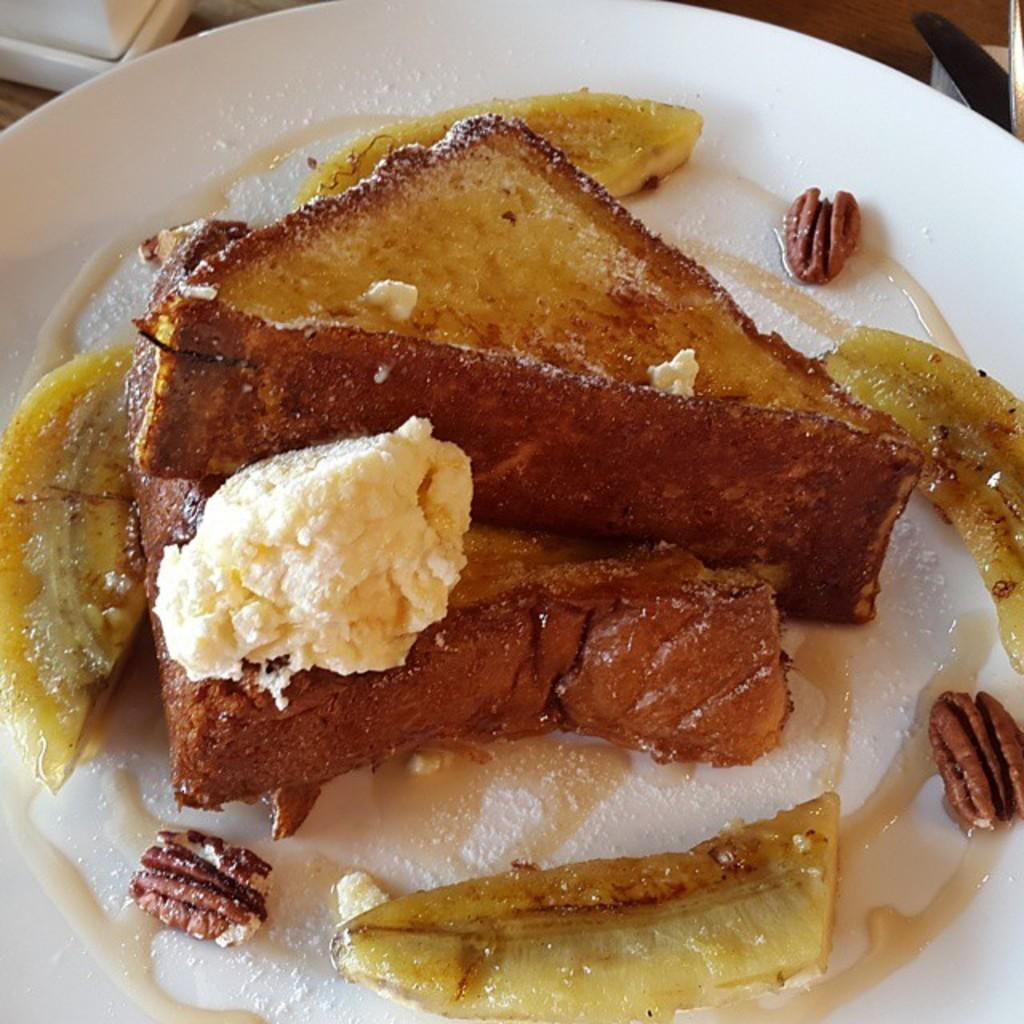What is on the plate that is visible in the image? There is a plate with food in the image. Where is the plate located in the image? The plate is on a wooden surface, which likely represents a table. Is there a fire burning in the cave near the kettle in the image? There is no cave, fire, or kettle present in the image. 